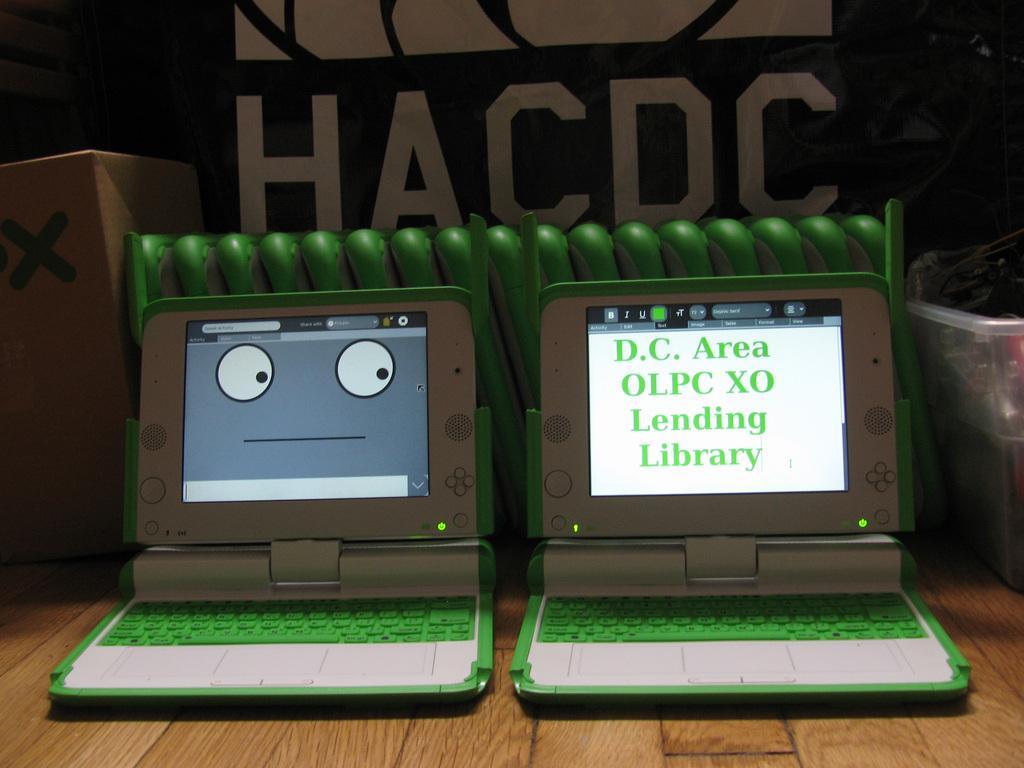Could you give a brief overview of what you see in this image? On this wooden surface there are laptops with screen. Here we can see a cardboard box and a container. 